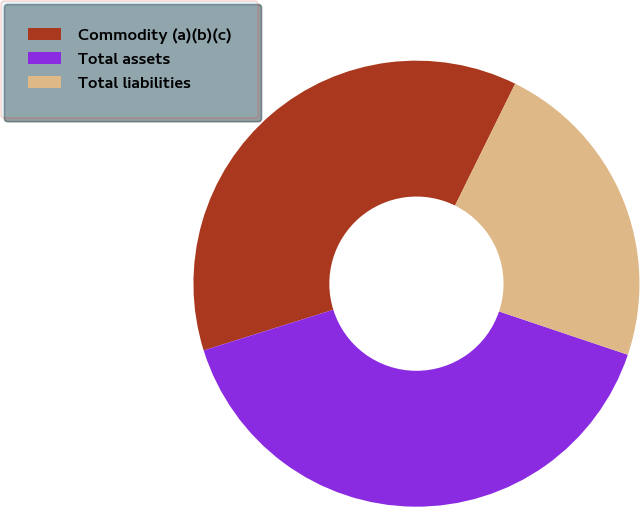Convert chart to OTSL. <chart><loc_0><loc_0><loc_500><loc_500><pie_chart><fcel>Commodity (a)(b)(c)<fcel>Total assets<fcel>Total liabilities<nl><fcel>37.14%<fcel>40.0%<fcel>22.86%<nl></chart> 